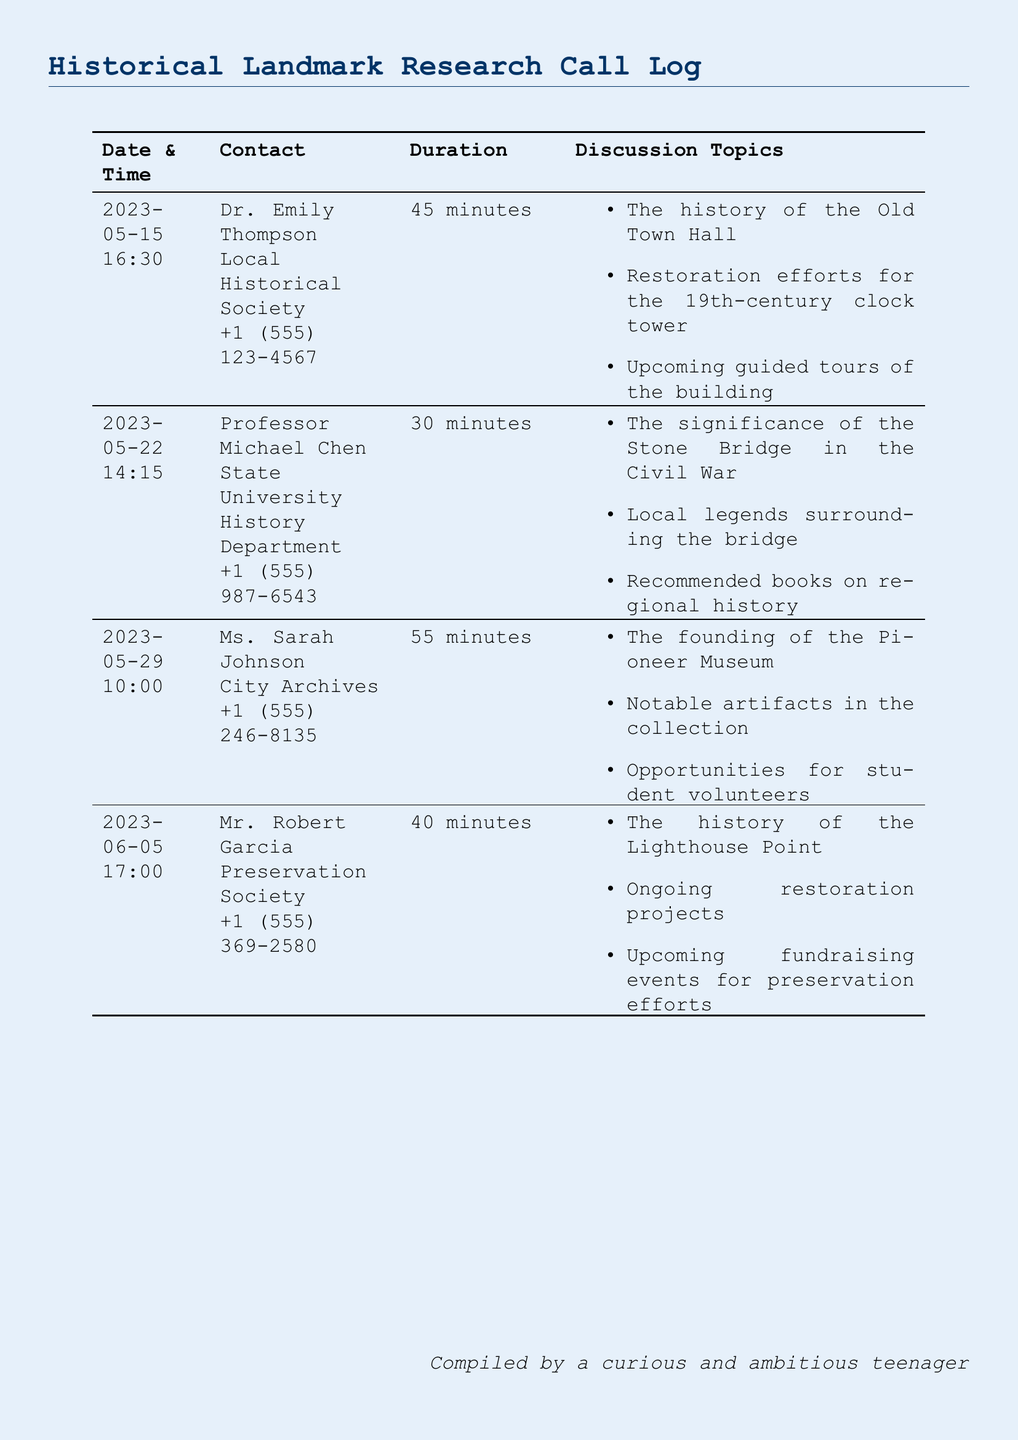What is the date of the call with Dr. Emily Thompson? The date of the call with Dr. Emily Thompson is listed in the document under her call entry.
Answer: 2023-05-15 How long was the conversation with Professor Michael Chen? The duration of the conversation with Professor Michael Chen can be found in the call log.
Answer: 30 minutes Who is the contact for the discussion about the Pioneer Museum? The contact for the discussion about the Pioneer Museum is identified in the call log entry corresponding to that topic.
Answer: Ms. Sarah Johnson What was one of the topics discussed during the call with Mr. Robert Garcia? The topics discussed with Mr. Robert Garcia are listed under his call entry.
Answer: The history of the Lighthouse Point How many minutes did the call with Ms. Sarah Johnson last? The duration of the call with Ms. Sarah Johnson is stated in the document.
Answer: 55 minutes What type of historical landmarks were discussed in these calls? The types of historical landmarks discussed can be inferred from the topics listed for each call.
Answer: Old Town Hall, Stone Bridge, Pioneer Museum, Lighthouse Point What is the name of the local historians contacted? The names of the local historians can be found in the contact section of each call entry.
Answer: Dr. Emily Thompson, Professor Michael Chen, Ms. Sarah Johnson, Mr. Robert Garcia What was one of the restoration efforts mentioned in the calls? The restoration efforts related to specific landmarks are included in the discussion topics of certain calls.
Answer: Restoration efforts for the 19th-century clock tower 